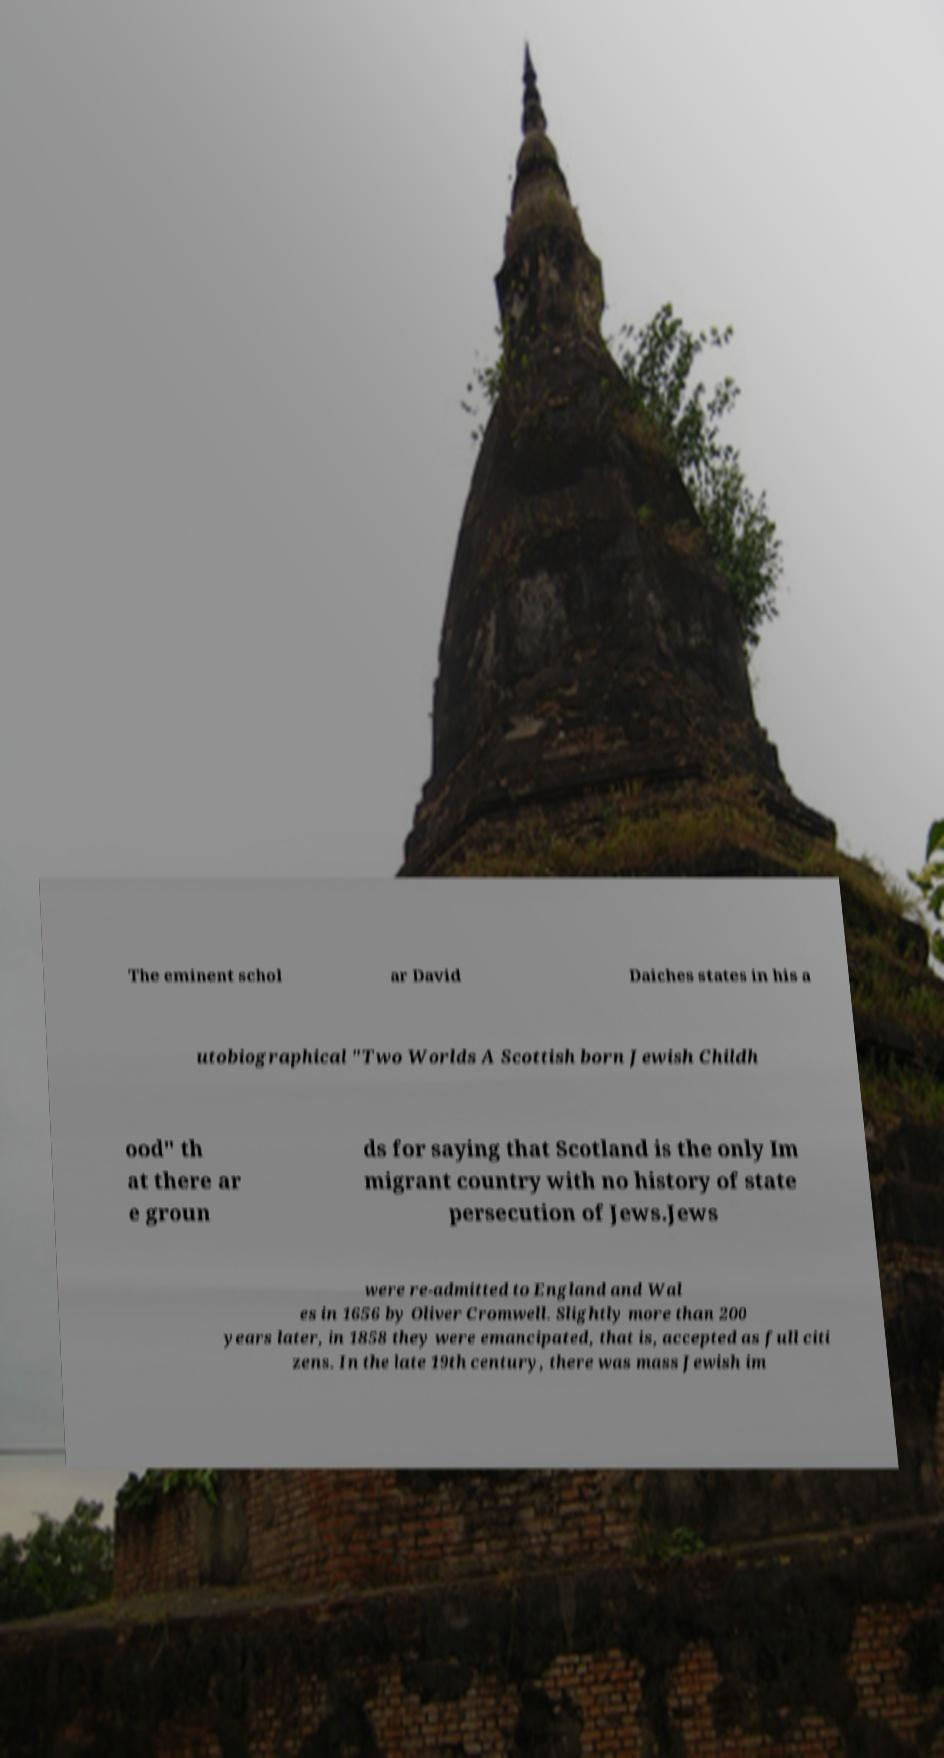Could you extract and type out the text from this image? The eminent schol ar David Daiches states in his a utobiographical "Two Worlds A Scottish born Jewish Childh ood" th at there ar e groun ds for saying that Scotland is the only Im migrant country with no history of state persecution of Jews.Jews were re-admitted to England and Wal es in 1656 by Oliver Cromwell. Slightly more than 200 years later, in 1858 they were emancipated, that is, accepted as full citi zens. In the late 19th century, there was mass Jewish im 